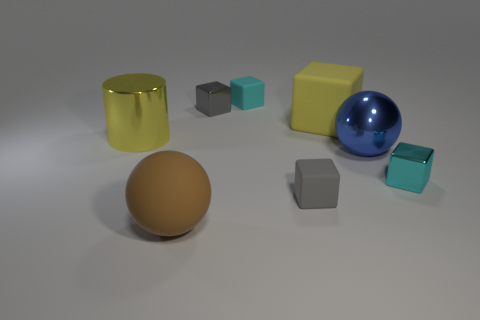Subtract all metallic cubes. How many cubes are left? 3 Subtract all cyan cubes. How many cubes are left? 3 Subtract 1 balls. How many balls are left? 1 Add 2 large blue metallic balls. How many objects exist? 10 Subtract all balls. How many objects are left? 6 Subtract all brown cylinders. How many red spheres are left? 0 Subtract 0 yellow balls. How many objects are left? 8 Subtract all cyan cylinders. Subtract all purple cubes. How many cylinders are left? 1 Subtract all large shiny things. Subtract all tiny cubes. How many objects are left? 2 Add 4 gray shiny things. How many gray shiny things are left? 5 